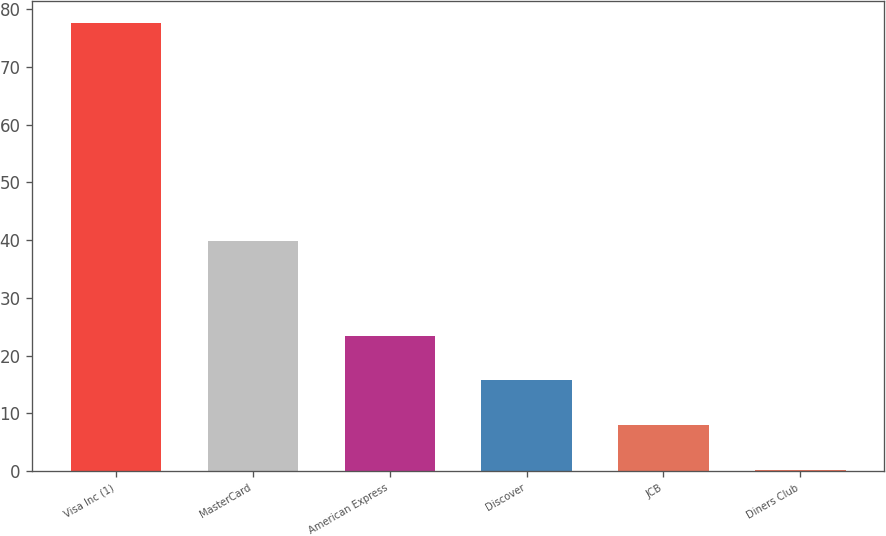Convert chart to OTSL. <chart><loc_0><loc_0><loc_500><loc_500><bar_chart><fcel>Visa Inc (1)<fcel>MasterCard<fcel>American Express<fcel>Discover<fcel>JCB<fcel>Diners Club<nl><fcel>77.6<fcel>39.8<fcel>23.42<fcel>15.68<fcel>7.94<fcel>0.2<nl></chart> 